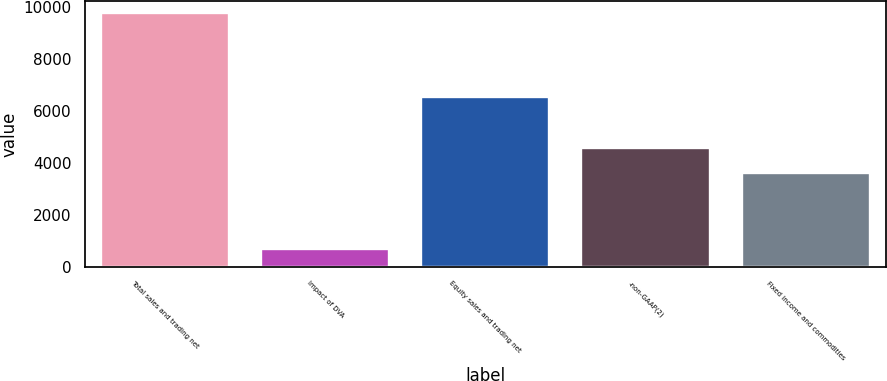<chart> <loc_0><loc_0><loc_500><loc_500><bar_chart><fcel>Total sales and trading net<fcel>Impact of DVA<fcel>Equity sales and trading net<fcel>-non-GAAP(2)<fcel>Fixed income and commodities<nl><fcel>9751<fcel>681<fcel>6529<fcel>4569.1<fcel>3594<nl></chart> 